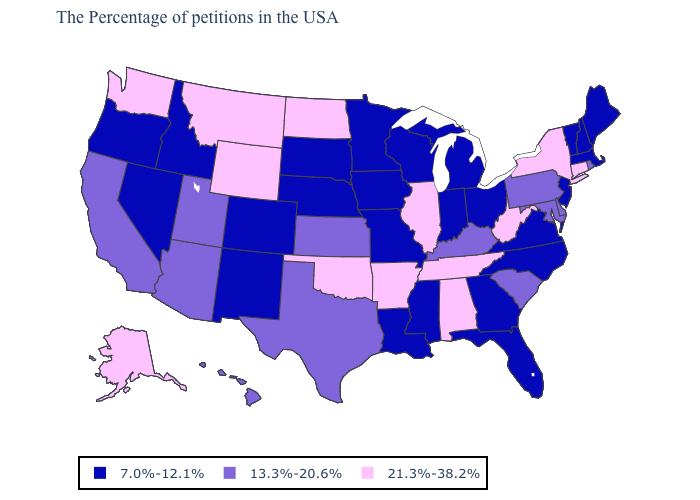Among the states that border New Jersey , which have the highest value?
Concise answer only. New York. Does Wyoming have the highest value in the West?
Write a very short answer. Yes. What is the lowest value in the USA?
Give a very brief answer. 7.0%-12.1%. Does the map have missing data?
Quick response, please. No. Does Arkansas have the highest value in the South?
Concise answer only. Yes. Among the states that border Ohio , does West Virginia have the highest value?
Be succinct. Yes. What is the value of Arizona?
Answer briefly. 13.3%-20.6%. What is the value of Maine?
Quick response, please. 7.0%-12.1%. Name the states that have a value in the range 13.3%-20.6%?
Short answer required. Rhode Island, Delaware, Maryland, Pennsylvania, South Carolina, Kentucky, Kansas, Texas, Utah, Arizona, California, Hawaii. Name the states that have a value in the range 7.0%-12.1%?
Answer briefly. Maine, Massachusetts, New Hampshire, Vermont, New Jersey, Virginia, North Carolina, Ohio, Florida, Georgia, Michigan, Indiana, Wisconsin, Mississippi, Louisiana, Missouri, Minnesota, Iowa, Nebraska, South Dakota, Colorado, New Mexico, Idaho, Nevada, Oregon. What is the value of North Carolina?
Write a very short answer. 7.0%-12.1%. Name the states that have a value in the range 7.0%-12.1%?
Concise answer only. Maine, Massachusetts, New Hampshire, Vermont, New Jersey, Virginia, North Carolina, Ohio, Florida, Georgia, Michigan, Indiana, Wisconsin, Mississippi, Louisiana, Missouri, Minnesota, Iowa, Nebraska, South Dakota, Colorado, New Mexico, Idaho, Nevada, Oregon. Name the states that have a value in the range 21.3%-38.2%?
Be succinct. Connecticut, New York, West Virginia, Alabama, Tennessee, Illinois, Arkansas, Oklahoma, North Dakota, Wyoming, Montana, Washington, Alaska. Is the legend a continuous bar?
Concise answer only. No. 